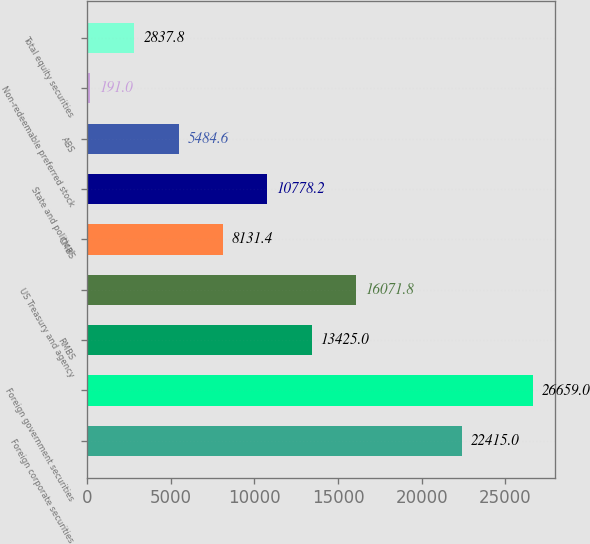Convert chart. <chart><loc_0><loc_0><loc_500><loc_500><bar_chart><fcel>Foreign corporate securities<fcel>Foreign government securities<fcel>RMBS<fcel>US Treasury and agency<fcel>CMBS<fcel>State and political<fcel>ABS<fcel>Non-redeemable preferred stock<fcel>Total equity securities<nl><fcel>22415<fcel>26659<fcel>13425<fcel>16071.8<fcel>8131.4<fcel>10778.2<fcel>5484.6<fcel>191<fcel>2837.8<nl></chart> 